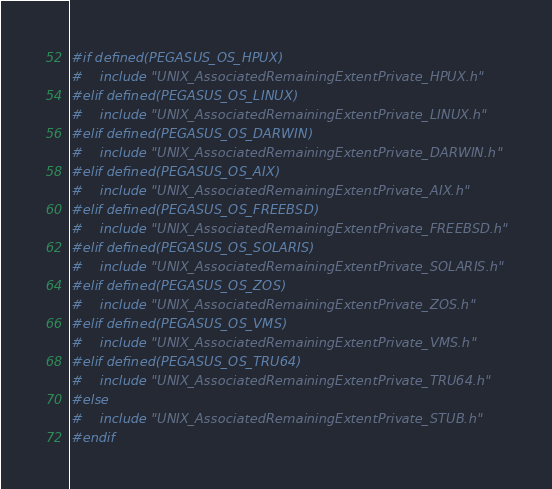Convert code to text. <code><loc_0><loc_0><loc_500><loc_500><_C_>
#if defined(PEGASUS_OS_HPUX)
#	include "UNIX_AssociatedRemainingExtentPrivate_HPUX.h"
#elif defined(PEGASUS_OS_LINUX)
#	include "UNIX_AssociatedRemainingExtentPrivate_LINUX.h"
#elif defined(PEGASUS_OS_DARWIN)
#	include "UNIX_AssociatedRemainingExtentPrivate_DARWIN.h"
#elif defined(PEGASUS_OS_AIX)
#	include "UNIX_AssociatedRemainingExtentPrivate_AIX.h"
#elif defined(PEGASUS_OS_FREEBSD)
#	include "UNIX_AssociatedRemainingExtentPrivate_FREEBSD.h"
#elif defined(PEGASUS_OS_SOLARIS)
#	include "UNIX_AssociatedRemainingExtentPrivate_SOLARIS.h"
#elif defined(PEGASUS_OS_ZOS)
#	include "UNIX_AssociatedRemainingExtentPrivate_ZOS.h"
#elif defined(PEGASUS_OS_VMS)
#	include "UNIX_AssociatedRemainingExtentPrivate_VMS.h"
#elif defined(PEGASUS_OS_TRU64)
#	include "UNIX_AssociatedRemainingExtentPrivate_TRU64.h"
#else
#	include "UNIX_AssociatedRemainingExtentPrivate_STUB.h"
#endif
</code> 